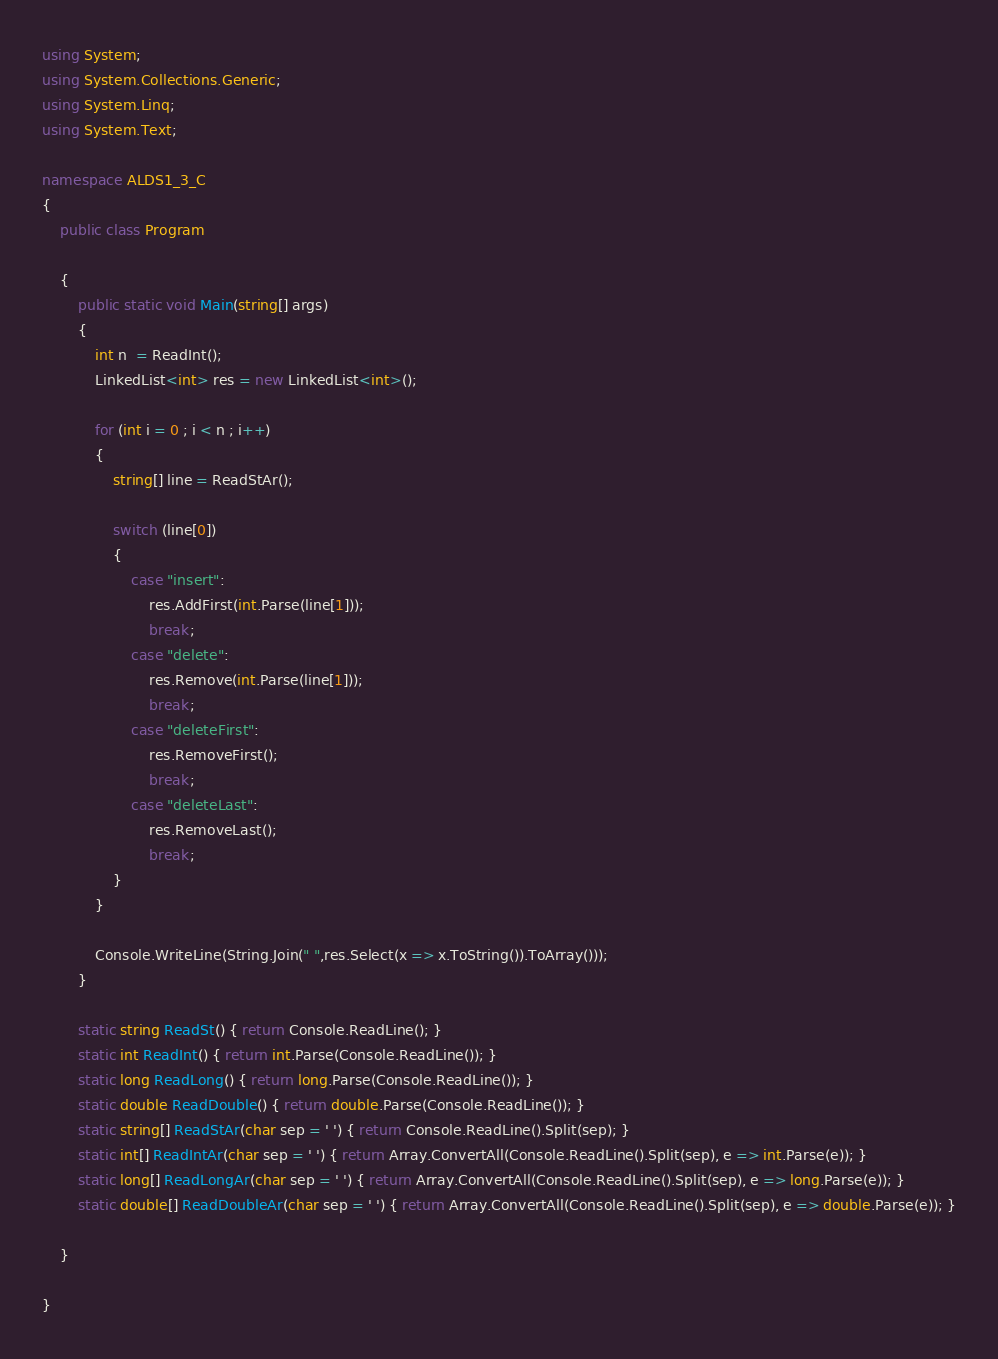Convert code to text. <code><loc_0><loc_0><loc_500><loc_500><_C#_>using System;
using System.Collections.Generic;
using System.Linq;
using System.Text;

namespace ALDS1_3_C
{
    public class Program

    {
        public static void Main(string[] args)
        {
            int n  = ReadInt();
            LinkedList<int> res = new LinkedList<int>();

            for (int i = 0 ; i < n ; i++)
            {
                string[] line = ReadStAr();

                switch (line[0])
                {
                    case "insert":
                        res.AddFirst(int.Parse(line[1]));
                        break;
                    case "delete":
                        res.Remove(int.Parse(line[1]));
                        break;
                    case "deleteFirst":
                        res.RemoveFirst();
                        break;
                    case "deleteLast":
                        res.RemoveLast();
                        break;
                }
            }

            Console.WriteLine(String.Join(" ",res.Select(x => x.ToString()).ToArray()));
        }

        static string ReadSt() { return Console.ReadLine(); }
        static int ReadInt() { return int.Parse(Console.ReadLine()); }
        static long ReadLong() { return long.Parse(Console.ReadLine()); }
        static double ReadDouble() { return double.Parse(Console.ReadLine()); }
        static string[] ReadStAr(char sep = ' ') { return Console.ReadLine().Split(sep); }
        static int[] ReadIntAr(char sep = ' ') { return Array.ConvertAll(Console.ReadLine().Split(sep), e => int.Parse(e)); }
        static long[] ReadLongAr(char sep = ' ') { return Array.ConvertAll(Console.ReadLine().Split(sep), e => long.Parse(e)); }
        static double[] ReadDoubleAr(char sep = ' ') { return Array.ConvertAll(Console.ReadLine().Split(sep), e => double.Parse(e)); }

    }

}

</code> 